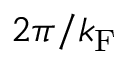<formula> <loc_0><loc_0><loc_500><loc_500>2 \pi / k _ { F }</formula> 